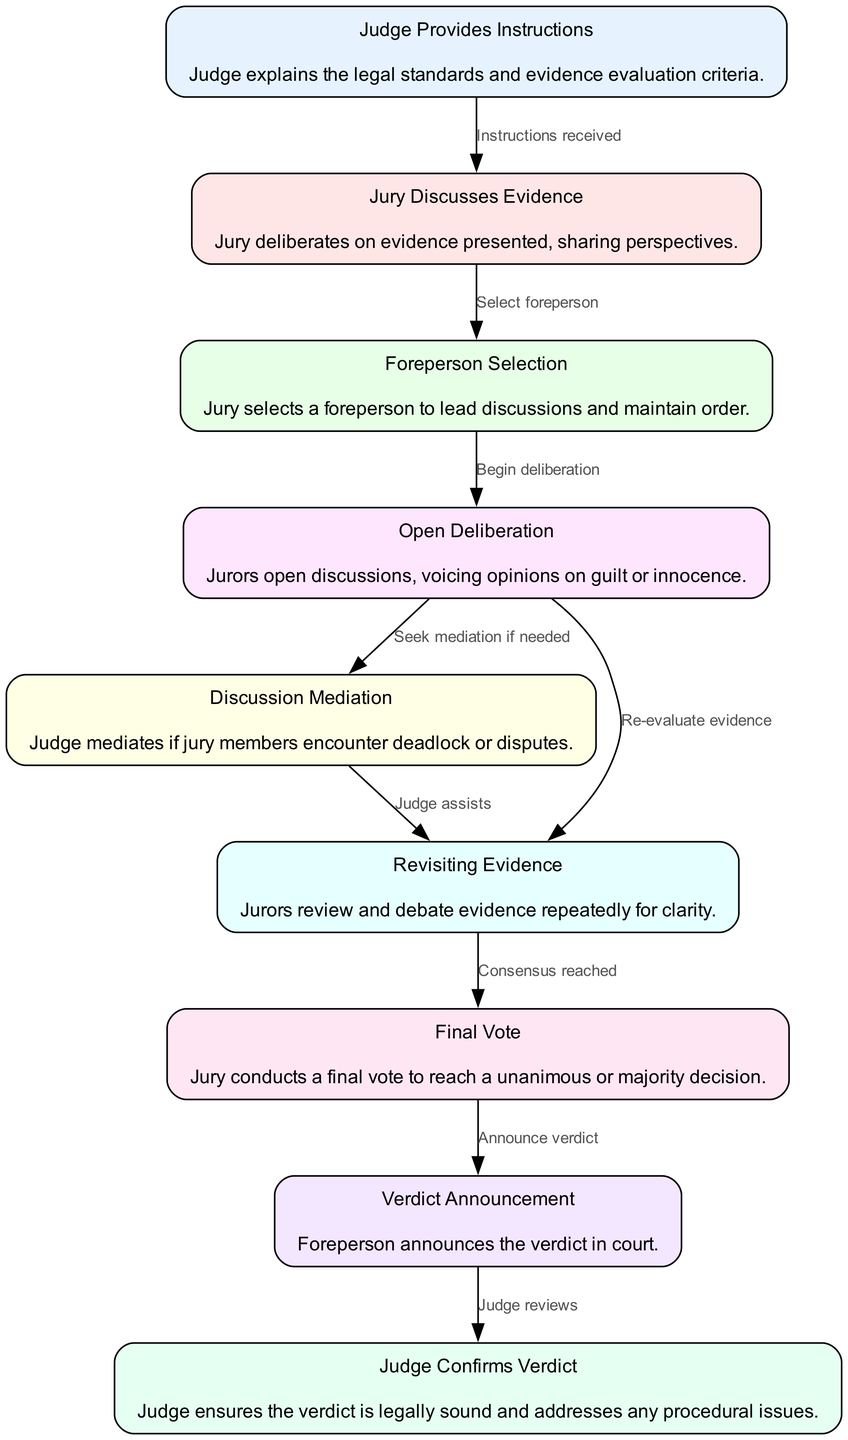What is the first step in the jury decision-making process? The first step is indicated by the node labeled "Judge Provides Instructions," which explains the legal standards and evidence evaluation criteria.
Answer: Judge Provides Instructions How many nodes are there in the diagram? By counting the nodes listed in the data, there are a total of nine distinct steps depicted in the jury decision-making process.
Answer: 9 Which node follows "Final Vote"? The node that directly follows "Final Vote" is "Verdict Announcement," which involves the foreperson announcing the verdict in court.
Answer: Verdict Announcement What role does the judge play during discussions? The diagram shows that the judge mediates any disputes if the jury encounters a deadlock during their discussions, ensuring fairness.
Answer: Mediation Which step involves selecting a foreperson? According to the diagram, the step labeled "Foreperson Selection" describes the process in which the jury selects a foreperson to lead discussions.
Answer: Foreperson Selection What is the outcome of the "Final Vote"? The outcome leads to a "Verdict Announcement," wherein the foreperson announces the decision made by the jury, either unanimously or by majority.
Answer: Verdict Announcement What is the relationship between "Open Deliberation" and "Revisiting Evidence"? "Open Deliberation" can lead to either "Discussion Mediation" or "Revisiting Evidence," as jurors may seek mediation or need to reevaluate evidence based on their discussions.
Answer: Seek mediation or reevaluate evidence What happens after the "Verdict Announcement"? After the "Verdict Announcement," the next step is for the "Judge Confirms Verdict," wherein the judge ensures the verdict is legally sound.
Answer: Judge Confirms Verdict How does the jury begin their deliberation? The jury begins their deliberation after selecting a foreperson, as indicated by the flow from the "Foreperson Selection" node to "Open Deliberation."
Answer: Begin deliberation 